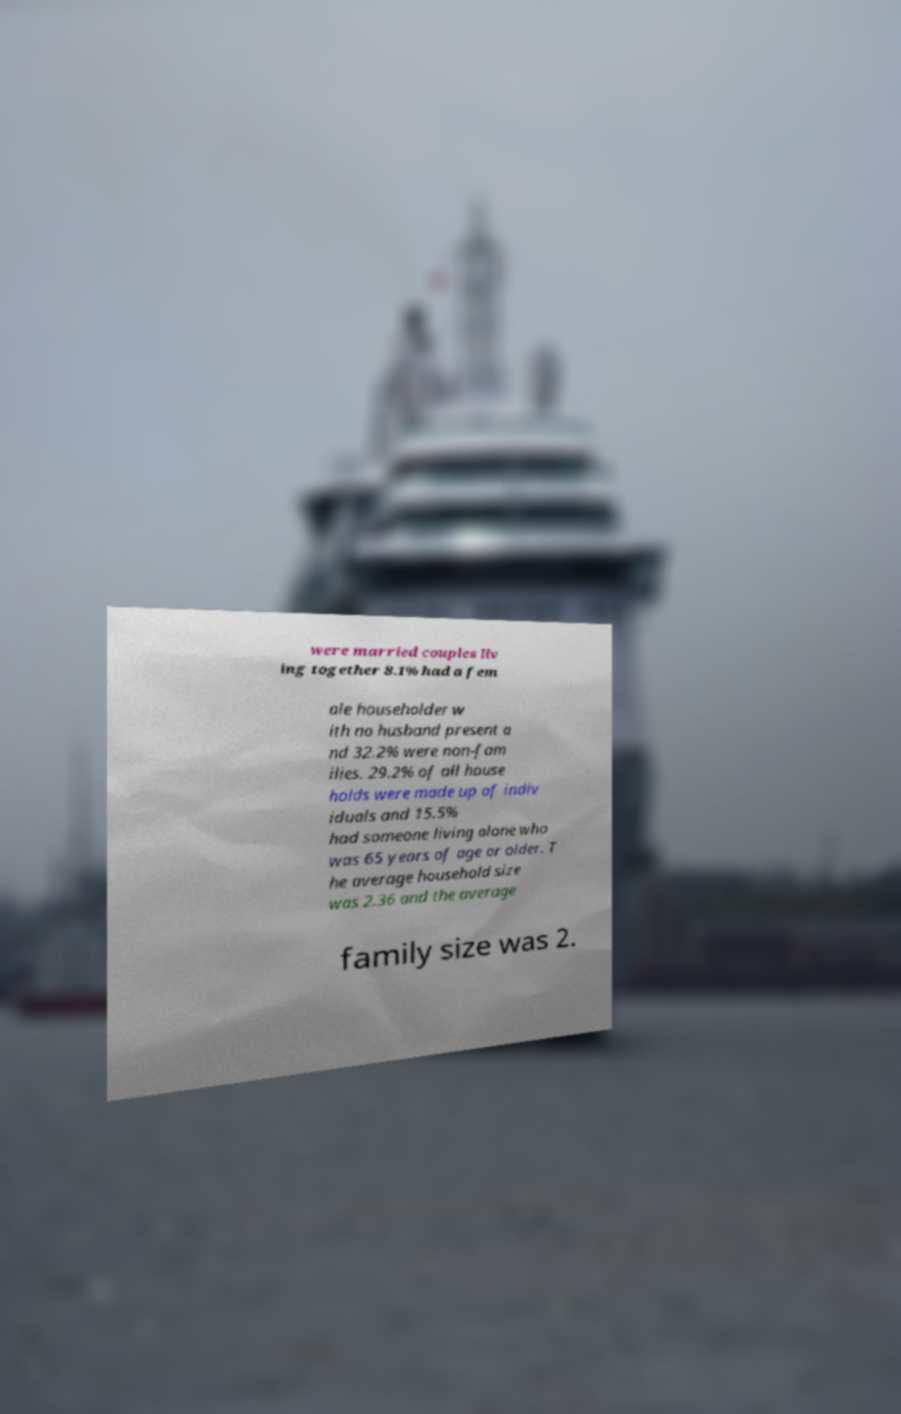Can you read and provide the text displayed in the image?This photo seems to have some interesting text. Can you extract and type it out for me? were married couples liv ing together 8.1% had a fem ale householder w ith no husband present a nd 32.2% were non-fam ilies. 29.2% of all house holds were made up of indiv iduals and 15.5% had someone living alone who was 65 years of age or older. T he average household size was 2.36 and the average family size was 2. 